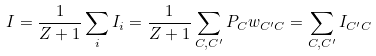Convert formula to latex. <formula><loc_0><loc_0><loc_500><loc_500>I = \frac { 1 } { Z + 1 } \sum _ { i } I _ { i } = \frac { 1 } { Z + 1 } \sum _ { C , C ^ { \prime } } P _ { C } w _ { C ^ { \prime } C } = \sum _ { C , C ^ { \prime } } I _ { C ^ { \prime } C }</formula> 